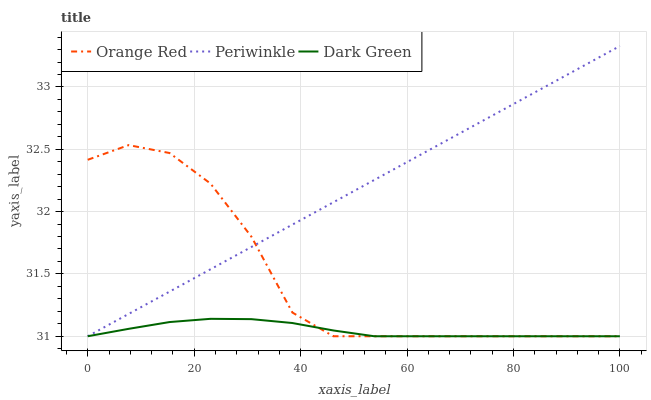Does Dark Green have the minimum area under the curve?
Answer yes or no. Yes. Does Periwinkle have the maximum area under the curve?
Answer yes or no. Yes. Does Orange Red have the minimum area under the curve?
Answer yes or no. No. Does Orange Red have the maximum area under the curve?
Answer yes or no. No. Is Periwinkle the smoothest?
Answer yes or no. Yes. Is Orange Red the roughest?
Answer yes or no. Yes. Is Dark Green the smoothest?
Answer yes or no. No. Is Dark Green the roughest?
Answer yes or no. No. Does Periwinkle have the lowest value?
Answer yes or no. Yes. Does Periwinkle have the highest value?
Answer yes or no. Yes. Does Orange Red have the highest value?
Answer yes or no. No. Does Orange Red intersect Dark Green?
Answer yes or no. Yes. Is Orange Red less than Dark Green?
Answer yes or no. No. Is Orange Red greater than Dark Green?
Answer yes or no. No. 